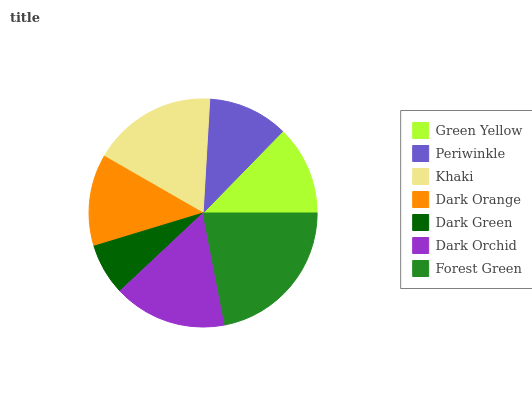Is Dark Green the minimum?
Answer yes or no. Yes. Is Forest Green the maximum?
Answer yes or no. Yes. Is Periwinkle the minimum?
Answer yes or no. No. Is Periwinkle the maximum?
Answer yes or no. No. Is Green Yellow greater than Periwinkle?
Answer yes or no. Yes. Is Periwinkle less than Green Yellow?
Answer yes or no. Yes. Is Periwinkle greater than Green Yellow?
Answer yes or no. No. Is Green Yellow less than Periwinkle?
Answer yes or no. No. Is Dark Orange the high median?
Answer yes or no. Yes. Is Dark Orange the low median?
Answer yes or no. Yes. Is Forest Green the high median?
Answer yes or no. No. Is Periwinkle the low median?
Answer yes or no. No. 